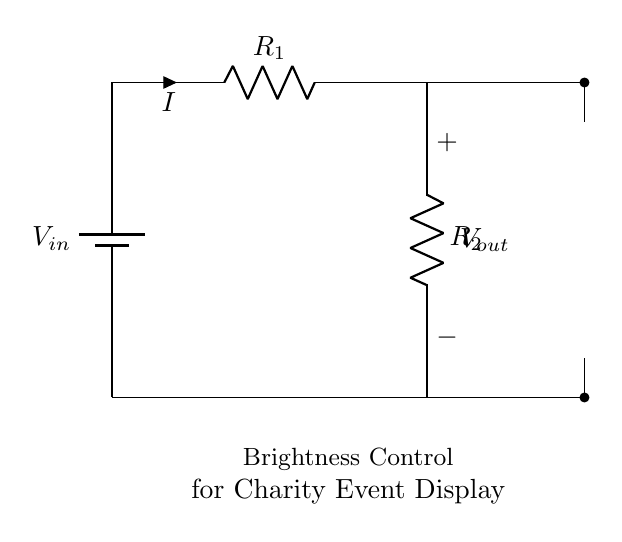What is the function of the LED in this circuit? The LED serves as an indicator that shows whether the circuit is powered and provides visual feedback corresponding to the brightness level controlled by the voltage divider.
Answer: Indicator What are the two resistors labeled in the circuit? The resistors are labeled R one and R two, which are part of the voltage divider that adjusts the voltage output to control the brightness of the LED.
Answer: R one and R two How is the output voltage measured in this circuit? The output voltage is measured across R two, which is where the voltage drop occurs and dictates the brightness of the LED based on the division of input voltage between the resistors.
Answer: Across R two What is the input voltage represented by V in? The input voltage represented by V in is the total voltage supplied by the battery, which is necessary for the operation of the voltage divider circuit to adjust brightness.
Answer: Battery voltage What happens to the LED brightness if R one is increased? Increasing R one increases the resistance in the circuit, resulting in a lower voltage across R two, which decreases the brightness of the LED due to less current flowing through it.
Answer: Decreases What is the purpose of the voltage divider configuration? The purpose of the voltage divider configuration is to create a specific output voltage (V out) that can be adjusted to control the brightness of the LED used for the charity event displays.
Answer: Adjust brightness 